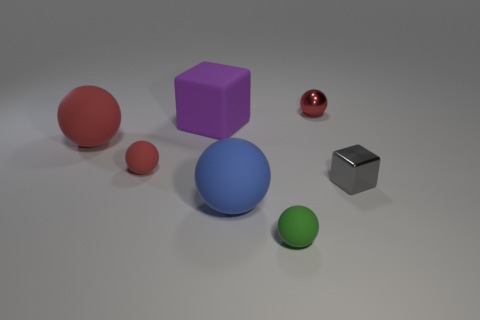The metal cube has what color?
Keep it short and to the point. Gray. Is there a red rubber ball behind the tiny rubber object that is on the right side of the blue rubber object?
Make the answer very short. Yes. What is the material of the big red sphere?
Provide a short and direct response. Rubber. Is the tiny red sphere that is on the left side of the green thing made of the same material as the small object behind the large red sphere?
Keep it short and to the point. No. Are there any other things that are the same color as the metallic ball?
Your response must be concise. Yes. What is the color of the other large matte thing that is the same shape as the large red matte thing?
Make the answer very short. Blue. What size is the sphere that is both on the right side of the big blue rubber thing and in front of the big purple rubber block?
Make the answer very short. Small. Is the shape of the small red object that is on the left side of the shiny sphere the same as the rubber thing on the right side of the blue rubber object?
Provide a short and direct response. Yes. What number of other things are made of the same material as the large purple thing?
Give a very brief answer. 4. What shape is the rubber thing that is both in front of the gray thing and on the left side of the green matte thing?
Provide a short and direct response. Sphere. 